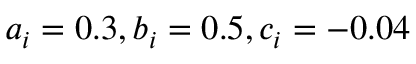<formula> <loc_0><loc_0><loc_500><loc_500>a _ { i } = 0 . 3 , b _ { i } = 0 . 5 , c _ { i } = - 0 . 0 4</formula> 